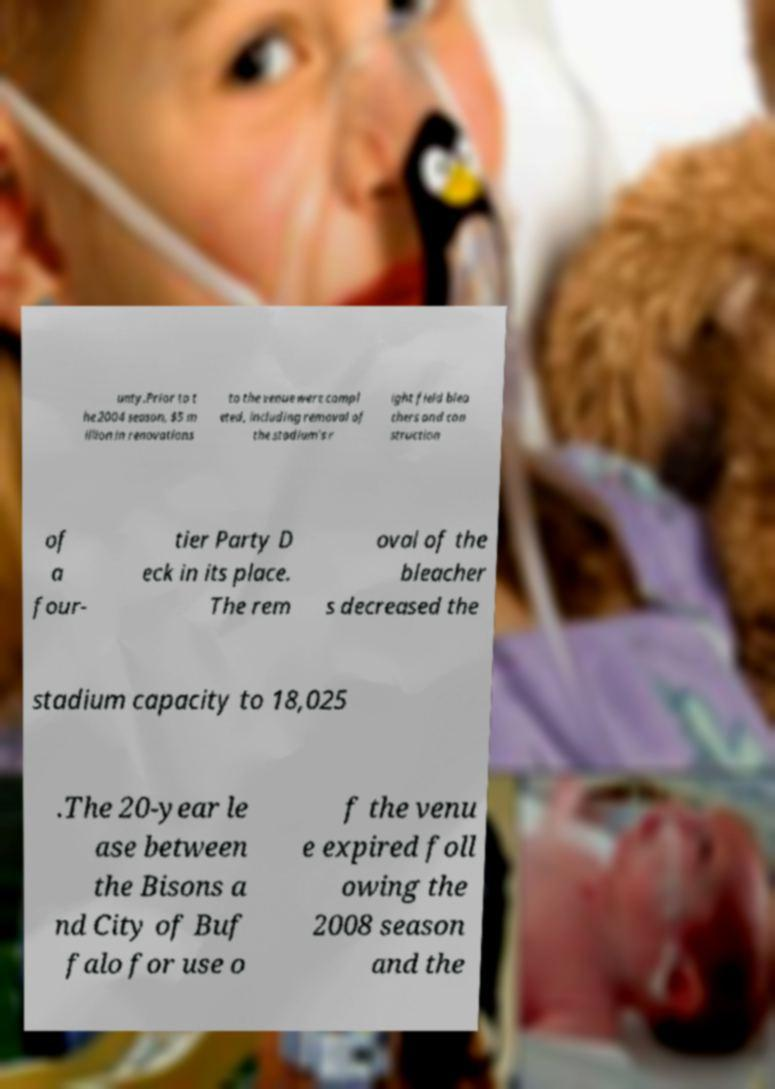For documentation purposes, I need the text within this image transcribed. Could you provide that? unty.Prior to t he 2004 season, $5 m illion in renovations to the venue were compl eted, including removal of the stadium's r ight field blea chers and con struction of a four- tier Party D eck in its place. The rem oval of the bleacher s decreased the stadium capacity to 18,025 .The 20-year le ase between the Bisons a nd City of Buf falo for use o f the venu e expired foll owing the 2008 season and the 